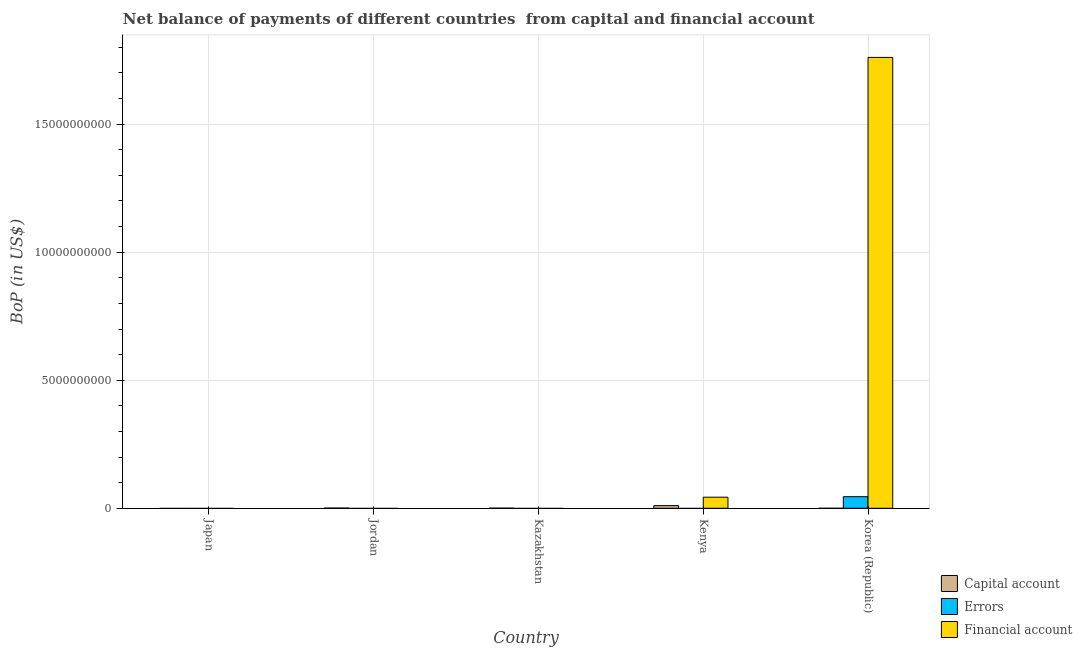How many bars are there on the 5th tick from the left?
Your answer should be very brief. 2. What is the label of the 3rd group of bars from the left?
Your answer should be compact. Kazakhstan. In how many cases, is the number of bars for a given country not equal to the number of legend labels?
Ensure brevity in your answer.  5. What is the amount of errors in Korea (Republic)?
Provide a succinct answer. 4.52e+08. Across all countries, what is the maximum amount of financial account?
Give a very brief answer. 1.76e+1. In which country was the amount of net capital account maximum?
Keep it short and to the point. Kenya. What is the total amount of errors in the graph?
Your response must be concise. 4.52e+08. What is the difference between the amount of net capital account in Jordan and that in Kazakhstan?
Your answer should be compact. 3.96e+06. What is the difference between the amount of net capital account in Japan and the amount of financial account in Kazakhstan?
Make the answer very short. 0. What is the average amount of net capital account per country?
Ensure brevity in your answer.  2.33e+07. What is the ratio of the amount of net capital account in Jordan to that in Kenya?
Provide a succinct answer. 0.08. What is the difference between the highest and the second highest amount of net capital account?
Your answer should be very brief. 9.49e+07. What is the difference between the highest and the lowest amount of errors?
Ensure brevity in your answer.  4.52e+08. In how many countries, is the amount of financial account greater than the average amount of financial account taken over all countries?
Provide a short and direct response. 1. Is it the case that in every country, the sum of the amount of net capital account and amount of errors is greater than the amount of financial account?
Your answer should be compact. No. How many bars are there?
Offer a very short reply. 6. Are all the bars in the graph horizontal?
Offer a terse response. No. How many countries are there in the graph?
Your response must be concise. 5. Does the graph contain grids?
Your answer should be very brief. Yes. Where does the legend appear in the graph?
Ensure brevity in your answer.  Bottom right. How many legend labels are there?
Offer a terse response. 3. What is the title of the graph?
Your response must be concise. Net balance of payments of different countries  from capital and financial account. What is the label or title of the Y-axis?
Give a very brief answer. BoP (in US$). What is the BoP (in US$) of Errors in Japan?
Your answer should be very brief. 0. What is the BoP (in US$) of Capital account in Jordan?
Give a very brief answer. 8.46e+06. What is the BoP (in US$) in Financial account in Jordan?
Ensure brevity in your answer.  0. What is the BoP (in US$) in Capital account in Kazakhstan?
Keep it short and to the point. 4.51e+06. What is the BoP (in US$) of Errors in Kazakhstan?
Give a very brief answer. 0. What is the BoP (in US$) of Capital account in Kenya?
Give a very brief answer. 1.03e+08. What is the BoP (in US$) in Financial account in Kenya?
Offer a terse response. 4.33e+08. What is the BoP (in US$) in Capital account in Korea (Republic)?
Your answer should be compact. 0. What is the BoP (in US$) of Errors in Korea (Republic)?
Offer a terse response. 4.52e+08. What is the BoP (in US$) of Financial account in Korea (Republic)?
Your answer should be very brief. 1.76e+1. Across all countries, what is the maximum BoP (in US$) in Capital account?
Provide a short and direct response. 1.03e+08. Across all countries, what is the maximum BoP (in US$) of Errors?
Keep it short and to the point. 4.52e+08. Across all countries, what is the maximum BoP (in US$) in Financial account?
Provide a succinct answer. 1.76e+1. Across all countries, what is the minimum BoP (in US$) in Errors?
Provide a short and direct response. 0. Across all countries, what is the minimum BoP (in US$) of Financial account?
Your answer should be compact. 0. What is the total BoP (in US$) of Capital account in the graph?
Your answer should be compact. 1.16e+08. What is the total BoP (in US$) in Errors in the graph?
Your response must be concise. 4.52e+08. What is the total BoP (in US$) of Financial account in the graph?
Give a very brief answer. 1.80e+1. What is the difference between the BoP (in US$) of Capital account in Jordan and that in Kazakhstan?
Make the answer very short. 3.96e+06. What is the difference between the BoP (in US$) of Capital account in Jordan and that in Kenya?
Provide a succinct answer. -9.49e+07. What is the difference between the BoP (in US$) of Capital account in Kazakhstan and that in Kenya?
Your response must be concise. -9.88e+07. What is the difference between the BoP (in US$) of Financial account in Kenya and that in Korea (Republic)?
Provide a succinct answer. -1.72e+1. What is the difference between the BoP (in US$) of Capital account in Jordan and the BoP (in US$) of Financial account in Kenya?
Your answer should be compact. -4.24e+08. What is the difference between the BoP (in US$) in Capital account in Jordan and the BoP (in US$) in Errors in Korea (Republic)?
Offer a terse response. -4.44e+08. What is the difference between the BoP (in US$) of Capital account in Jordan and the BoP (in US$) of Financial account in Korea (Republic)?
Give a very brief answer. -1.76e+1. What is the difference between the BoP (in US$) in Capital account in Kazakhstan and the BoP (in US$) in Financial account in Kenya?
Your response must be concise. -4.28e+08. What is the difference between the BoP (in US$) in Capital account in Kazakhstan and the BoP (in US$) in Errors in Korea (Republic)?
Provide a short and direct response. -4.48e+08. What is the difference between the BoP (in US$) of Capital account in Kazakhstan and the BoP (in US$) of Financial account in Korea (Republic)?
Your answer should be very brief. -1.76e+1. What is the difference between the BoP (in US$) of Capital account in Kenya and the BoP (in US$) of Errors in Korea (Republic)?
Give a very brief answer. -3.49e+08. What is the difference between the BoP (in US$) of Capital account in Kenya and the BoP (in US$) of Financial account in Korea (Republic)?
Provide a succinct answer. -1.75e+1. What is the average BoP (in US$) in Capital account per country?
Offer a very short reply. 2.33e+07. What is the average BoP (in US$) in Errors per country?
Give a very brief answer. 9.05e+07. What is the average BoP (in US$) in Financial account per country?
Give a very brief answer. 3.61e+09. What is the difference between the BoP (in US$) of Capital account and BoP (in US$) of Financial account in Kenya?
Offer a very short reply. -3.29e+08. What is the difference between the BoP (in US$) in Errors and BoP (in US$) in Financial account in Korea (Republic)?
Your response must be concise. -1.72e+1. What is the ratio of the BoP (in US$) of Capital account in Jordan to that in Kazakhstan?
Keep it short and to the point. 1.88. What is the ratio of the BoP (in US$) of Capital account in Jordan to that in Kenya?
Ensure brevity in your answer.  0.08. What is the ratio of the BoP (in US$) in Capital account in Kazakhstan to that in Kenya?
Ensure brevity in your answer.  0.04. What is the ratio of the BoP (in US$) in Financial account in Kenya to that in Korea (Republic)?
Offer a terse response. 0.02. What is the difference between the highest and the second highest BoP (in US$) in Capital account?
Offer a very short reply. 9.49e+07. What is the difference between the highest and the lowest BoP (in US$) of Capital account?
Your answer should be very brief. 1.03e+08. What is the difference between the highest and the lowest BoP (in US$) of Errors?
Offer a very short reply. 4.52e+08. What is the difference between the highest and the lowest BoP (in US$) in Financial account?
Provide a short and direct response. 1.76e+1. 